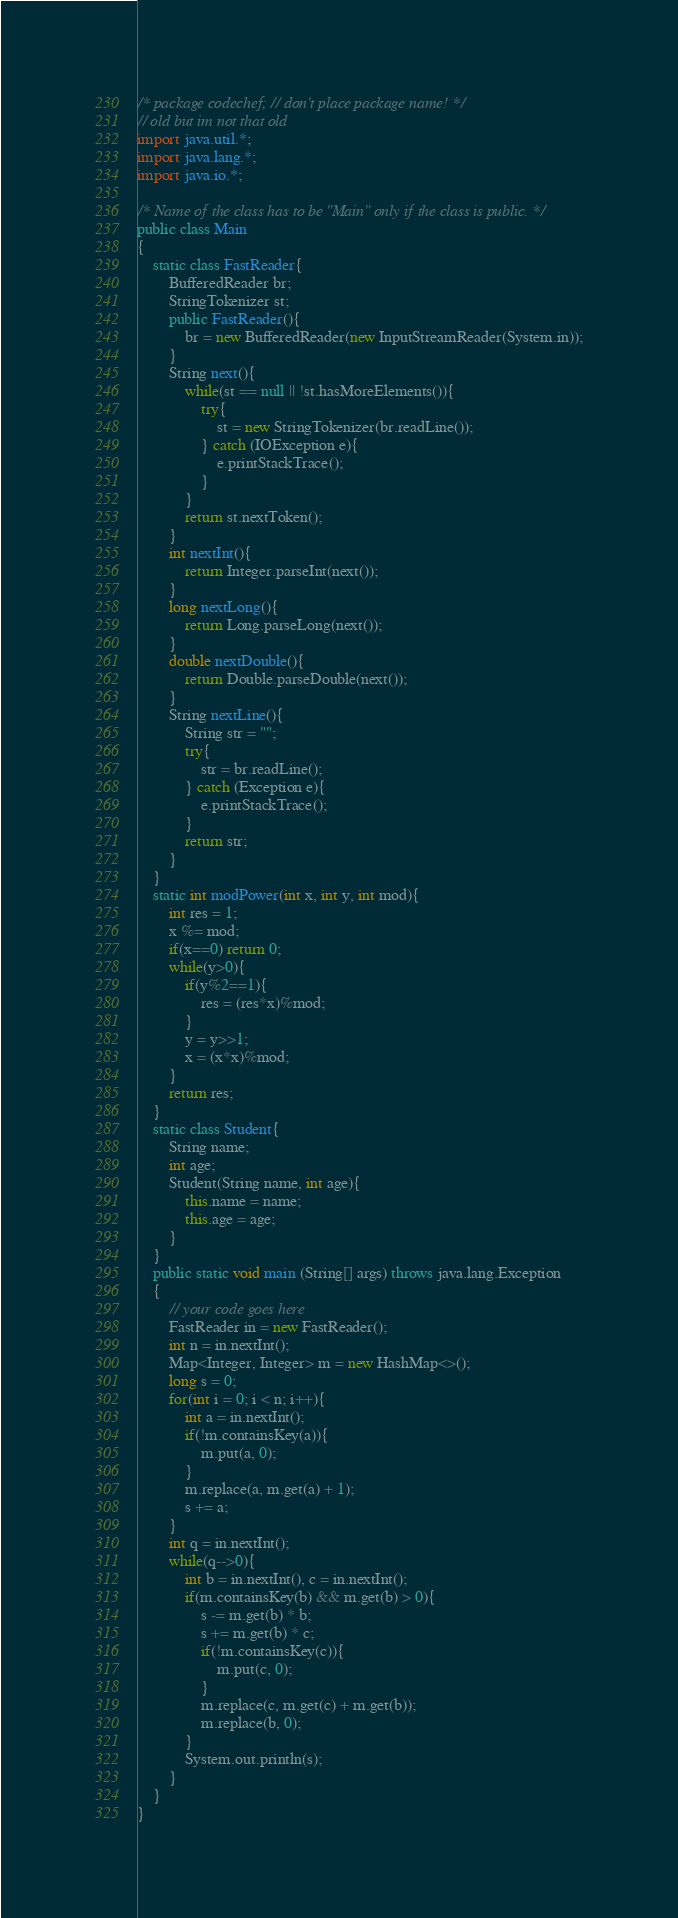<code> <loc_0><loc_0><loc_500><loc_500><_Java_>/* package codechef; // don't place package name! */
// old but im not that old
import java.util.*;
import java.lang.*;
import java.io.*;

/* Name of the class has to be "Main" only if the class is public. */
public class Main
{
    static class FastReader{
        BufferedReader br;
        StringTokenizer st;
        public FastReader(){
            br = new BufferedReader(new InputStreamReader(System.in));
        }
        String next(){
            while(st == null || !st.hasMoreElements()){
                try{
                    st = new StringTokenizer(br.readLine());
                } catch (IOException e){
                    e.printStackTrace();
                }
            }
            return st.nextToken();
        }
        int nextInt(){
            return Integer.parseInt(next());
        }
        long nextLong(){
            return Long.parseLong(next());
        }
        double nextDouble(){
            return Double.parseDouble(next());
        }
        String nextLine(){
            String str = "";
            try{
                str = br.readLine();
            } catch (Exception e){
                e.printStackTrace();
            }
            return str;
        }
    }
    static int modPower(int x, int y, int mod){
        int res = 1;
        x %= mod;
        if(x==0) return 0;
        while(y>0){
            if(y%2==1){
                res = (res*x)%mod;
            }
            y = y>>1;
            x = (x*x)%mod;
        }
        return res;
    }
    static class Student{
        String name;
        int age;
        Student(String name, int age){
            this.name = name;
            this.age = age;
        }
    }
    public static void main (String[] args) throws java.lang.Exception
    {
        // your code goes here
        FastReader in = new FastReader();
        int n = in.nextInt();
        Map<Integer, Integer> m = new HashMap<>();
        long s = 0;
        for(int i = 0; i < n; i++){
            int a = in.nextInt();
            if(!m.containsKey(a)){
                m.put(a, 0);
            }
            m.replace(a, m.get(a) + 1);
            s += a;
        }
        int q = in.nextInt();
        while(q-->0){
            int b = in.nextInt(), c = in.nextInt();
            if(m.containsKey(b) && m.get(b) > 0){
                s -= m.get(b) * b;
                s += m.get(b) * c;
                if(!m.containsKey(c)){
                    m.put(c, 0);
                }
                m.replace(c, m.get(c) + m.get(b));
                m.replace(b, 0);
            }
            System.out.println(s);
        }
    }
}
</code> 